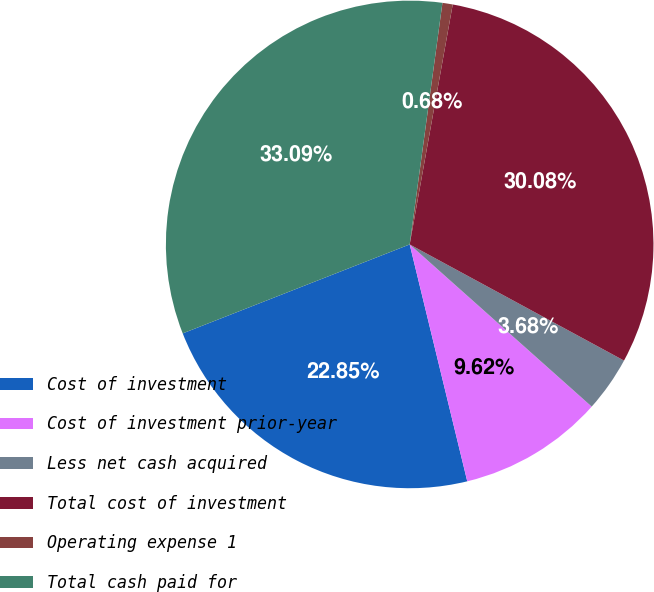Convert chart to OTSL. <chart><loc_0><loc_0><loc_500><loc_500><pie_chart><fcel>Cost of investment<fcel>Cost of investment prior-year<fcel>Less net cash acquired<fcel>Total cost of investment<fcel>Operating expense 1<fcel>Total cash paid for<nl><fcel>22.85%<fcel>9.62%<fcel>3.68%<fcel>30.08%<fcel>0.68%<fcel>33.09%<nl></chart> 